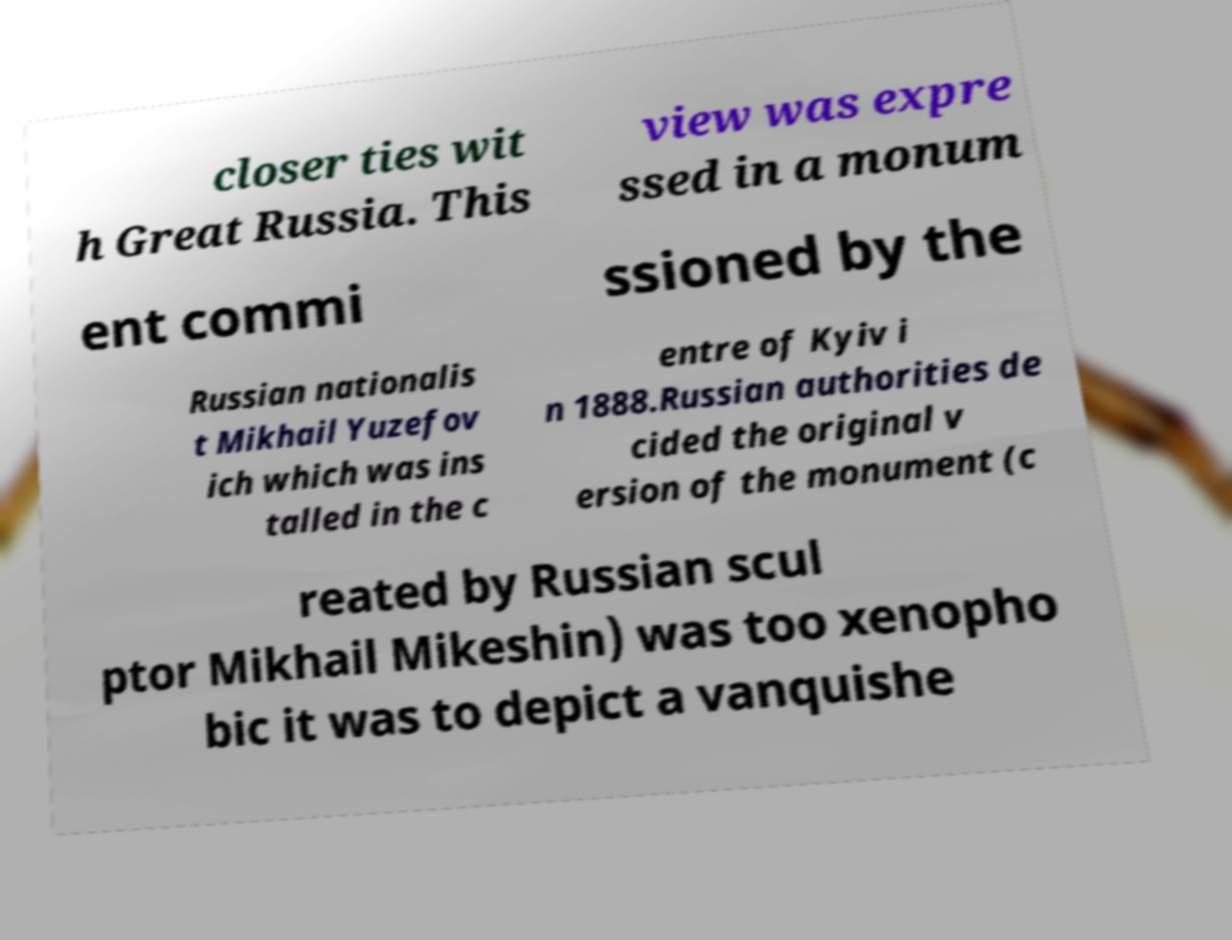Could you extract and type out the text from this image? closer ties wit h Great Russia. This view was expre ssed in a monum ent commi ssioned by the Russian nationalis t Mikhail Yuzefov ich which was ins talled in the c entre of Kyiv i n 1888.Russian authorities de cided the original v ersion of the monument (c reated by Russian scul ptor Mikhail Mikeshin) was too xenopho bic it was to depict a vanquishe 